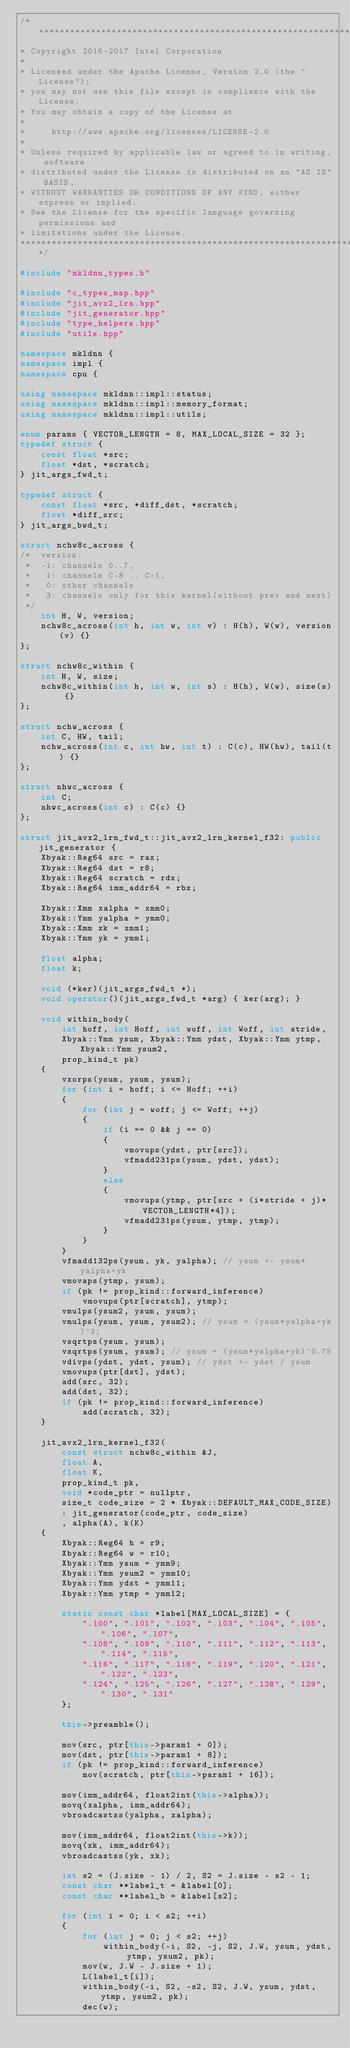Convert code to text. <code><loc_0><loc_0><loc_500><loc_500><_C++_>/*******************************************************************************
* Copyright 2016-2017 Intel Corporation
*
* Licensed under the Apache License, Version 2.0 (the "License");
* you may not use this file except in compliance with the License.
* You may obtain a copy of the License at
*
*     http://www.apache.org/licenses/LICENSE-2.0
*
* Unless required by applicable law or agreed to in writing, software
* distributed under the License is distributed on an "AS IS" BASIS,
* WITHOUT WARRANTIES OR CONDITIONS OF ANY KIND, either express or implied.
* See the License for the specific language governing permissions and
* limitations under the License.
*******************************************************************************/

#include "mkldnn_types.h"

#include "c_types_map.hpp"
#include "jit_avx2_lrn.hpp"
#include "jit_generator.hpp"
#include "type_helpers.hpp"
#include "utils.hpp"

namespace mkldnn {
namespace impl {
namespace cpu {

using namespace mkldnn::impl::status;
using namespace mkldnn::impl::memory_format;
using namespace mkldnn::impl::utils;

enum params { VECTOR_LENGTH = 8, MAX_LOCAL_SIZE = 32 };
typedef struct {
    const float *src;
    float *dst, *scratch;
} jit_args_fwd_t;

typedef struct {
    const float *src, *diff_dst, *scratch;
    float *diff_src;
} jit_args_bwd_t;

struct nchw8c_across {
/*  version:
 *  -1: channels 0..7,
 *   1: channels C-8 .. C-1,
 *   0: other channels
 *   3: channels only for this kernel(without prev and next)
 */
    int H, W, version;
    nchw8c_across(int h, int w, int v) : H(h), W(w), version(v) {}
};

struct nchw8c_within {
    int H, W, size;
    nchw8c_within(int h, int w, int s) : H(h), W(w), size(s) {}
};

struct nchw_across {
    int C, HW, tail;
    nchw_across(int c, int hw, int t) : C(c), HW(hw), tail(t) {}
};

struct nhwc_across {
    int C;
    nhwc_across(int c) : C(c) {}
};

struct jit_avx2_lrn_fwd_t::jit_avx2_lrn_kernel_f32: public jit_generator {
    Xbyak::Reg64 src = rax;
    Xbyak::Reg64 dst = r8;
    Xbyak::Reg64 scratch = rdx;
    Xbyak::Reg64 imm_addr64 = rbx;

    Xbyak::Xmm xalpha = xmm0;
    Xbyak::Ymm yalpha = ymm0;
    Xbyak::Xmm xk = xmm1;
    Xbyak::Ymm yk = ymm1;

    float alpha;
    float k;

    void (*ker)(jit_args_fwd_t *);
    void operator()(jit_args_fwd_t *arg) { ker(arg); }

    void within_body(
        int hoff, int Hoff, int woff, int Woff, int stride,
        Xbyak::Ymm ysum, Xbyak::Ymm ydst, Xbyak::Ymm ytmp, Xbyak::Ymm ysum2,
        prop_kind_t pk)
    {
        vxorps(ysum, ysum, ysum);
        for (int i = hoff; i <= Hoff; ++i)
        {
            for (int j = woff; j <= Woff; ++j)
            {
                if (i == 0 && j == 0)
                {
                    vmovups(ydst, ptr[src]);
                    vfmadd231ps(ysum, ydst, ydst);
                }
                else
                {
                    vmovups(ytmp, ptr[src + (i*stride + j)*VECTOR_LENGTH*4]);
                    vfmadd231ps(ysum, ytmp, ytmp);
                }
            }
        }
        vfmadd132ps(ysum, yk, yalpha); // ysum <- ysum*yalpha+yk
        vmovaps(ytmp, ysum);
        if (pk != prop_kind::forward_inference)
            vmovups(ptr[scratch], ytmp);
        vmulps(ysum2, ysum, ysum);
        vmulps(ysum, ysum, ysum2); // ysum = (ysum*yalpha+yk)^3;
        vsqrtps(ysum, ysum);
        vsqrtps(ysum, ysum); // ysum = (ysum*yalpha+yk)^0.75
        vdivps(ydst, ydst, ysum); // ydst <- ydst / ysum
        vmovups(ptr[dst], ydst);
        add(src, 32);
        add(dst, 32);
        if (pk != prop_kind::forward_inference)
            add(scratch, 32);
    }

    jit_avx2_lrn_kernel_f32(
        const struct nchw8c_within &J,
        float A,
        float K,
        prop_kind_t pk,
        void *code_ptr = nullptr,
        size_t code_size = 2 * Xbyak::DEFAULT_MAX_CODE_SIZE)
        : jit_generator(code_ptr, code_size)
        , alpha(A), k(K)
    {
        Xbyak::Reg64 h = r9;
        Xbyak::Reg64 w = r10;
        Xbyak::Ymm ysum = ymm9;
        Xbyak::Ymm ysum2 = ymm10;
        Xbyak::Ymm ydst = ymm11;
        Xbyak::Ymm ytmp = ymm12;

        static const char *label[MAX_LOCAL_SIZE] = {
            ".l00", ".l01", ".l02", ".l03", ".l04", ".l05", ".l06", ".l07",
            ".l08", ".l09", ".l10", ".l11", ".l12", ".l13", ".l14", ".l15",
            ".l16", ".l17", ".l18", ".l19", ".l20", ".l21", ".l22", ".l23",
            ".l24", ".l25", ".l26", ".l27", ".l28", ".l29", ".l30", ".l31"
        };

        this->preamble();

        mov(src, ptr[this->param1 + 0]);
        mov(dst, ptr[this->param1 + 8]);
        if (pk != prop_kind::forward_inference)
            mov(scratch, ptr[this->param1 + 16]);

        mov(imm_addr64, float2int(this->alpha));
        movq(xalpha, imm_addr64);
        vbroadcastss(yalpha, xalpha);

        mov(imm_addr64, float2int(this->k));
        movq(xk, imm_addr64);
        vbroadcastss(yk, xk);

        int s2 = (J.size - 1) / 2, S2 = J.size - s2 - 1;
        const char **label_t = &label[0];
        const char **label_b = &label[s2];

        for (int i = 0; i < s2; ++i)
        {
            for (int j = 0; j < s2; ++j)
                within_body(-i, S2, -j, S2, J.W, ysum, ydst, ytmp, ysum2, pk);
            mov(w, J.W - J.size + 1);
            L(label_t[i]);
            within_body(-i, S2, -s2, S2, J.W, ysum, ydst, ytmp, ysum2, pk);
            dec(w);</code> 